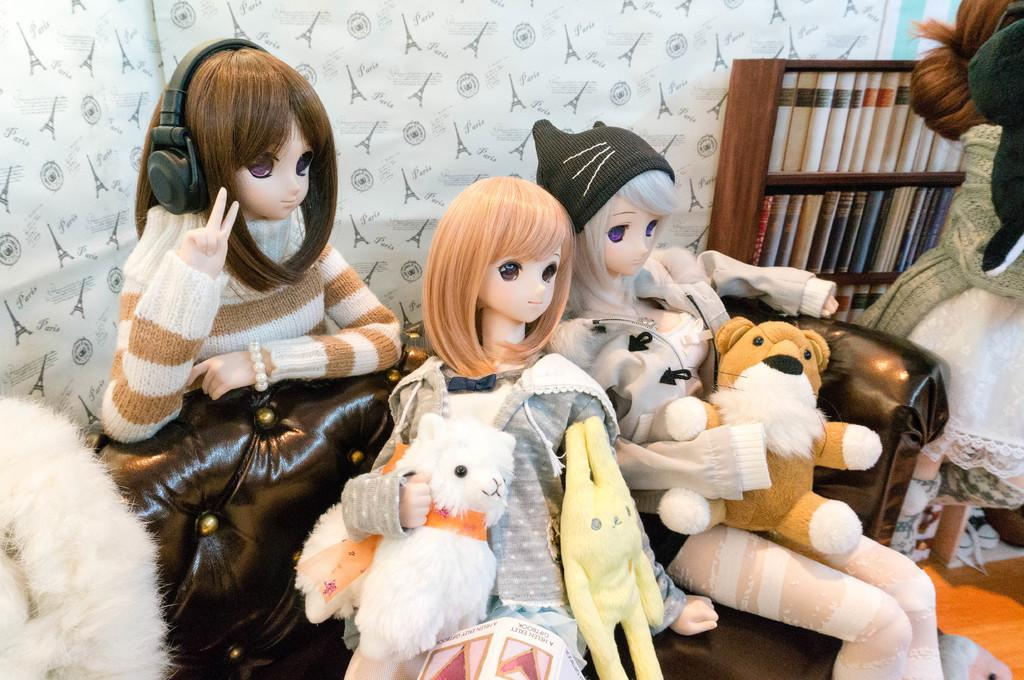What objects can be seen at the bottom of the image? There are toys present at the bottom of the image. What can be seen in the background of the image? There is a wall visible in the background of the image. What type of berry can be seen growing on the wall in the image? There are no berries visible on the wall in the image. What type of lock is present on the toys in the image? There are no locks present on the toys in the image. 